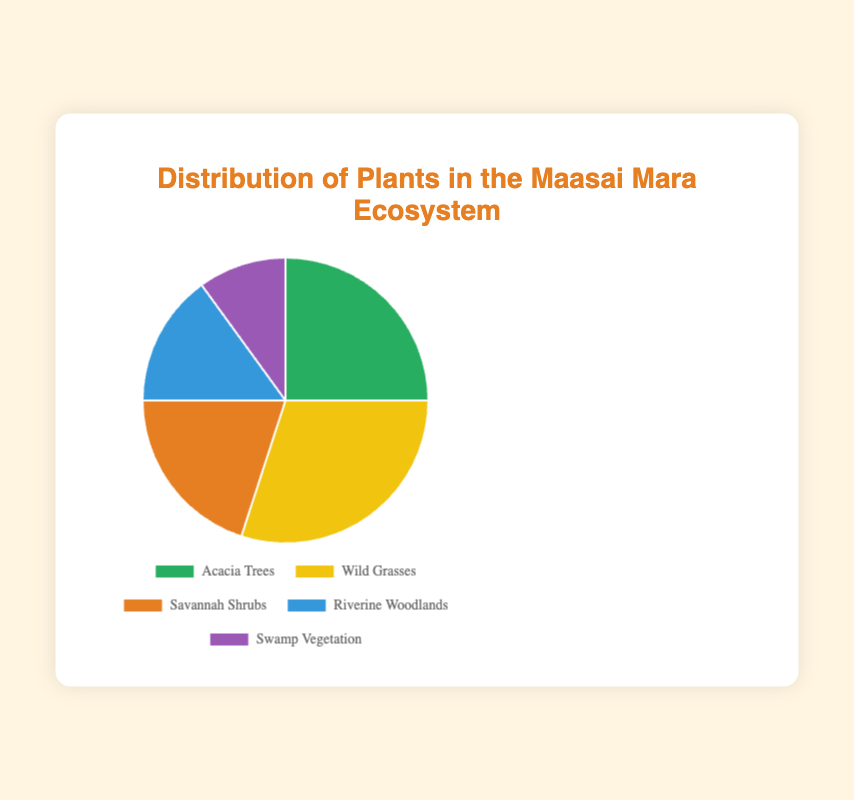What percentage of the ecosystem is made up of Savannah Shrubs? Look at the segment labeled "Savannah Shrubs" on the pie chart. The percentage is directly labeled there.
Answer: 20% Which plant type has a greater percentage: Wild Grasses or Acacia Trees? Locate both segments on the pie chart. Wild Grasses have a percentage of 30%, while Acacia Trees have 25%. Compare the two values.
Answer: Wild Grasses What's the sum of the percentages of Swamp Vegetation and Riverine Woodlands? Find the percentages for Swamp Vegetation and Riverine Woodlands, which are 10% and 15% respectively. Add these two values together: 10 + 15.
Answer: 25% Which plant type represents the smallest percentage of the ecosystem? Identify the segment with the smallest value. Swamp Vegetation has the smallest percentage of 10%.
Answer: Swamp Vegetation What percentage of the ecosystem is not made up of Wild Grasses? The percentage of Wild Grasses is 30%. Subtract this from 100% to find the percentage not made up of Wild Grasses: 100 - 30.
Answer: 70% How do the percentages of Acacia Trees and Savannah Shrubs compare to each other visually? Visually, Acacia Trees take up slightly more space than Savannah Shrubs. Acacia Trees are at 25% while Savannah Shrubs are at 20%.
Answer: Acacia Trees are greater If you combine the percentages for Acacia Trees and Savannah Shrubs, what fraction of the ecosystem do they represent? Add the percentages of Acacia Trees and Savannah Shrubs: 25 + 20 = 45%. This is nearly half (or 45/100) of the ecosystem.
Answer: 45% How much larger in terms of percentage is Wild Grasses compared to Swamp Vegetation? Subtract the percentage of Swamp Vegetation from Wild Grasses: 30 - 10 = 20%.
Answer: 20% What is the average percentage of all the plant types in the pie chart? Add the percentages of all plant types: 25 + 30 + 20 + 15 + 10 = 100. Divide by the number of plant types (5): 100 / 5.
Answer: 20% Identify the color used to represent Riverine Woodlands on the pie chart. Observe the segment labeled "Riverine Woodlands" on the pie chart. It is colored in a particular shade that can be identified visually.
Answer: Blue 